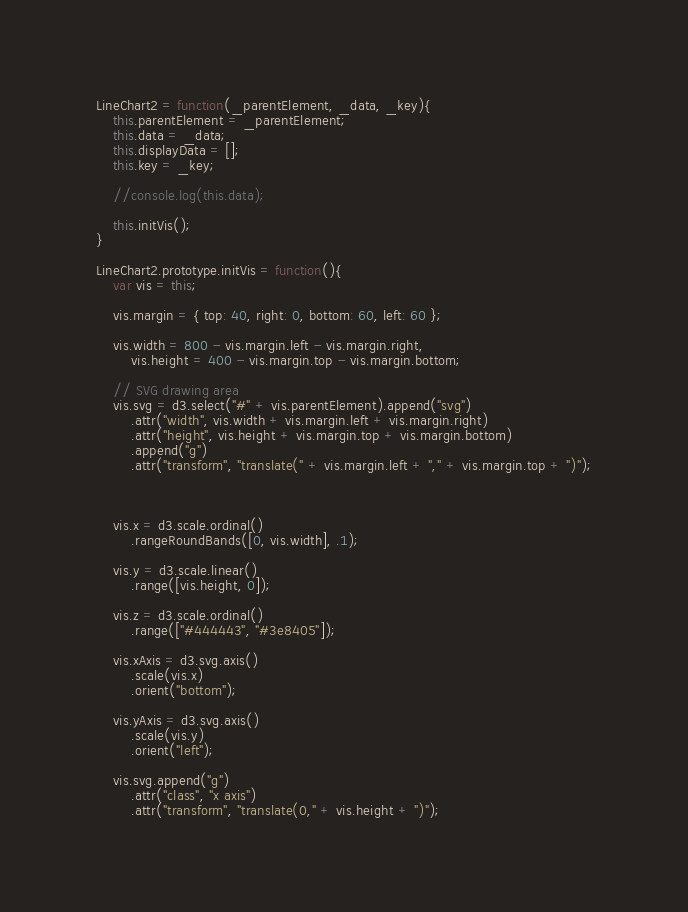<code> <loc_0><loc_0><loc_500><loc_500><_JavaScript_>LineChart2 = function(_parentElement, _data, _key){
    this.parentElement = _parentElement;
    this.data = _data;
    this.displayData = [];
    this.key = _key;

    //console.log(this.data);

    this.initVis();
}

LineChart2.prototype.initVis = function(){
    var vis = this;

    vis.margin = { top: 40, right: 0, bottom: 60, left: 60 };

    vis.width = 800 - vis.margin.left - vis.margin.right,
        vis.height = 400 - vis.margin.top - vis.margin.bottom;

    // SVG drawing area
    vis.svg = d3.select("#" + vis.parentElement).append("svg")
        .attr("width", vis.width + vis.margin.left + vis.margin.right)
        .attr("height", vis.height + vis.margin.top + vis.margin.bottom)
        .append("g")
        .attr("transform", "translate(" + vis.margin.left + "," + vis.margin.top + ")");



    vis.x = d3.scale.ordinal()
        .rangeRoundBands([0, vis.width], .1);

    vis.y = d3.scale.linear()
        .range([vis.height, 0]);

    vis.z = d3.scale.ordinal()
        .range(["#444443", "#3e8405"]);

    vis.xAxis = d3.svg.axis()
        .scale(vis.x)
        .orient("bottom");

    vis.yAxis = d3.svg.axis()
        .scale(vis.y)
        .orient("left");

    vis.svg.append("g")
        .attr("class", "x axis")
        .attr("transform", "translate(0," + vis.height + ")");
</code> 